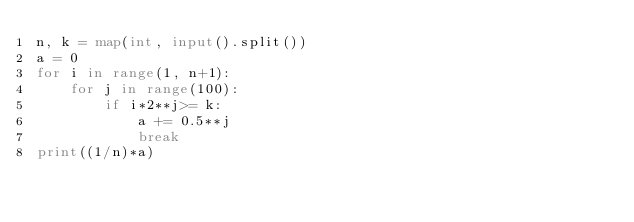<code> <loc_0><loc_0><loc_500><loc_500><_Python_>n, k = map(int, input().split())
a = 0
for i in range(1, n+1):
    for j in range(100):
        if i*2**j>= k:
            a += 0.5**j
            break
print((1/n)*a)</code> 